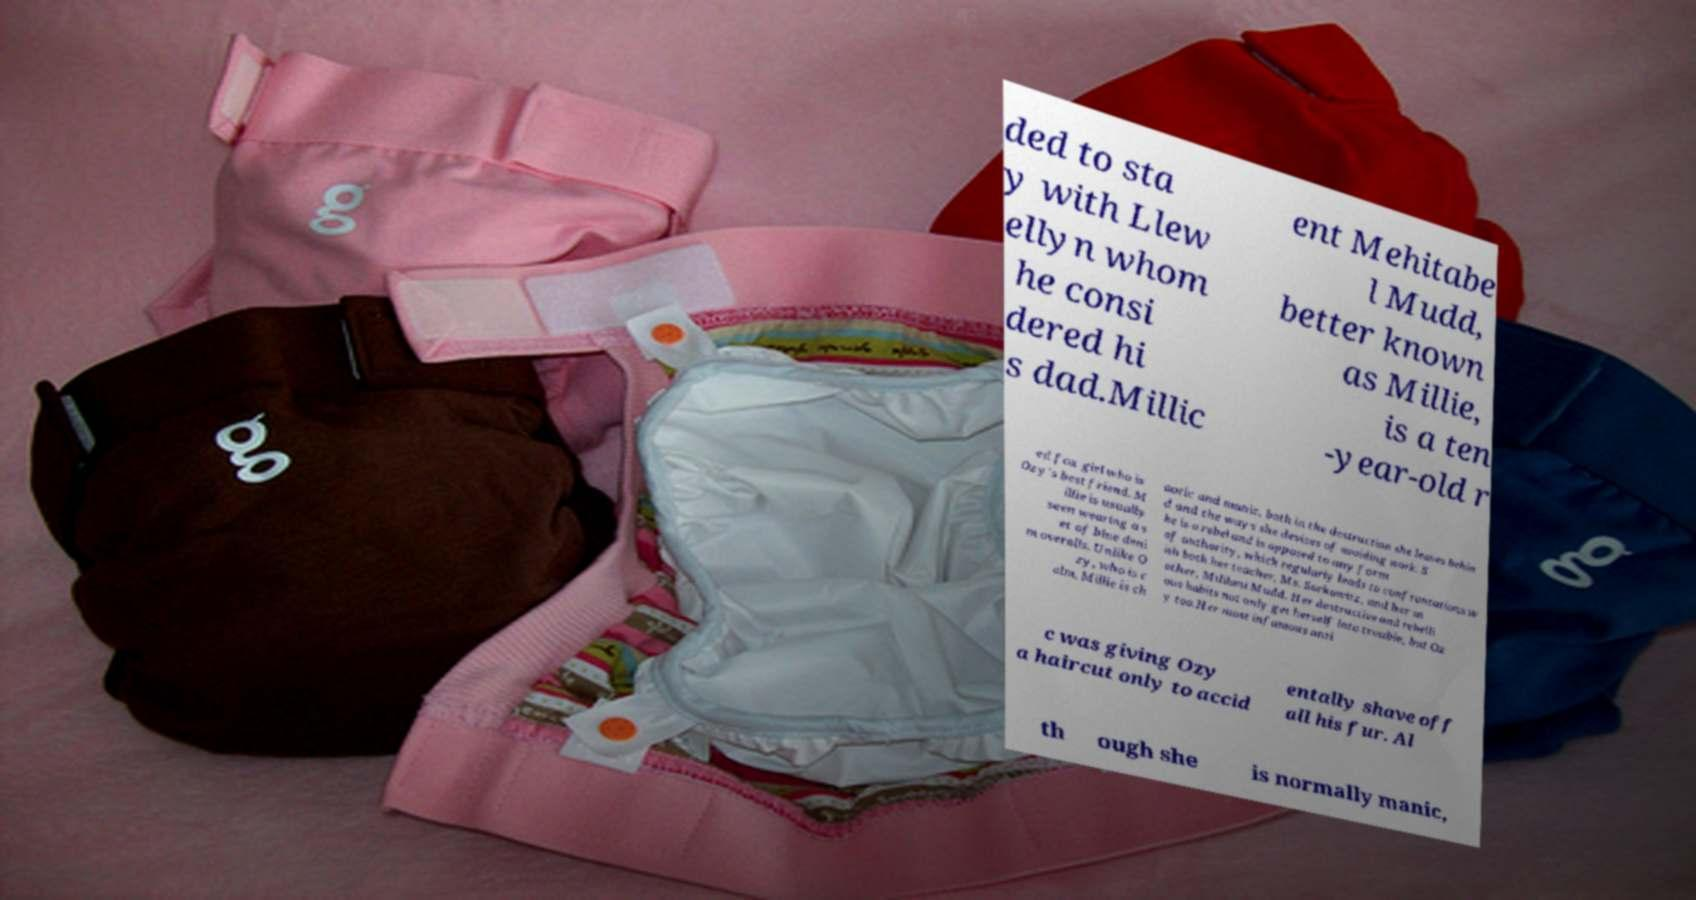For documentation purposes, I need the text within this image transcribed. Could you provide that? ded to sta y with Llew ellyn whom he consi dered hi s dad.Millic ent Mehitabe l Mudd, better known as Millie, is a ten -year-old r ed fox girl who is Ozy's best friend. M illie is usually seen wearing a s et of blue deni m overalls. Unlike O zy, who is c alm, Millie is ch aotic and manic, both in the destruction she leaves behin d and the ways she devises of avoiding work. S he is a rebel and is opposed to any form of authority, which regularly leads to confrontations w ith both her teacher, Ms. Sorkowitz, and her m other, Mililani Mudd. Her destructive and rebelli ous habits not only get herself into trouble, but Oz y too.Her most infamous anti c was giving Ozy a haircut only to accid entally shave off all his fur. Al th ough she is normally manic, 